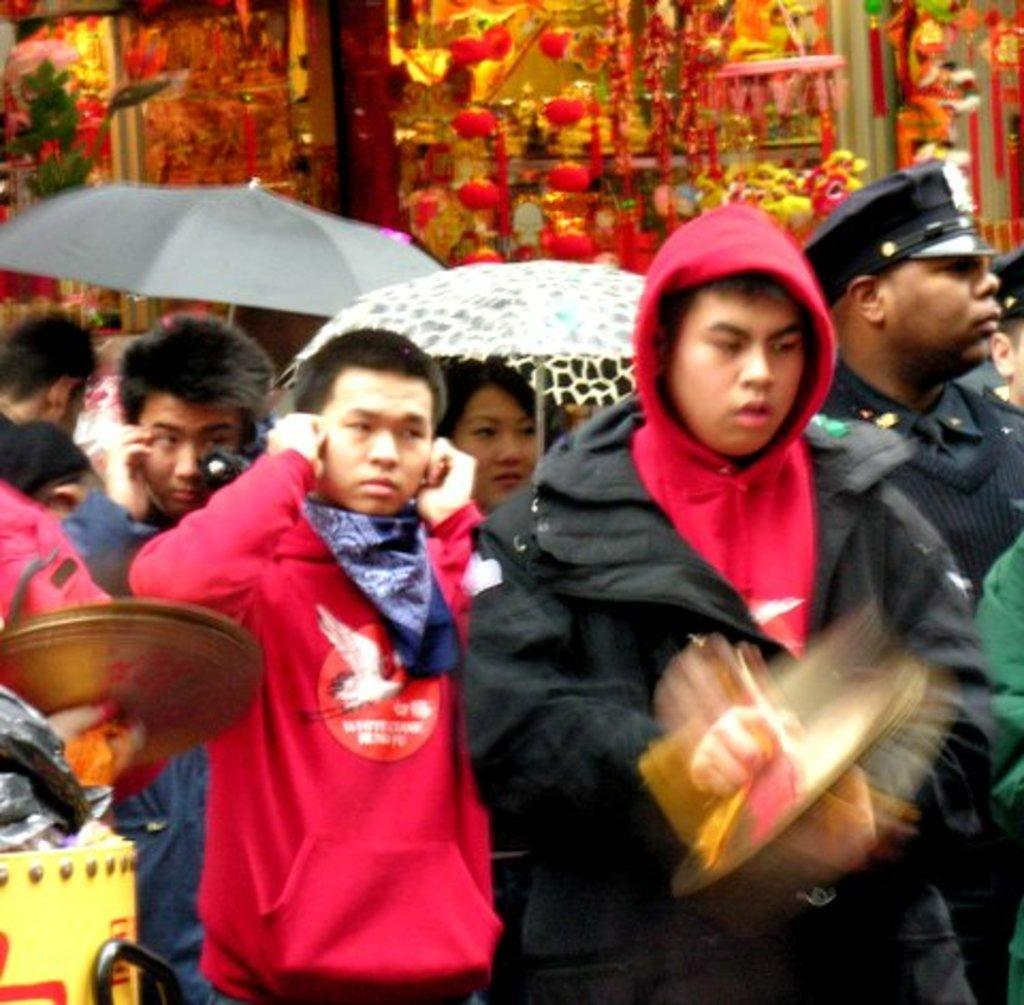Who or what is present in the image? There are people in the image. What are the people holding or using in the image? There are umbrellas in the image. What can be seen in the background of the image? There are objects and leaves in the background of the image. Where are additional objects located in the image? There are objects on the bottom left of the image. What type of eggs can be seen in the image? There are no eggs present in the image. What is the current weather like in the image? The image does not provide information about the weather, but the presence of umbrellas suggests that it might be raining or the people are prepared for rain. 